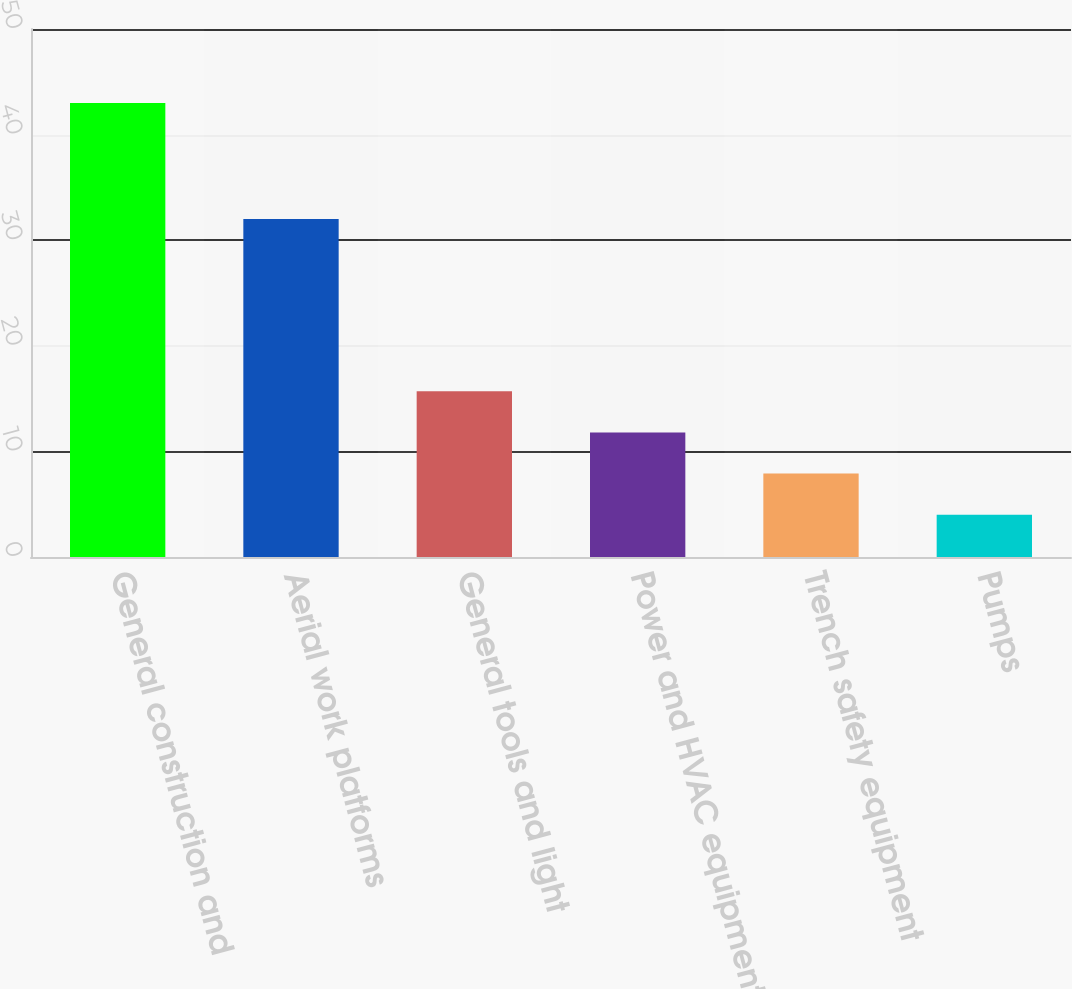Convert chart to OTSL. <chart><loc_0><loc_0><loc_500><loc_500><bar_chart><fcel>General construction and<fcel>Aerial work platforms<fcel>General tools and light<fcel>Power and HVAC equipment<fcel>Trench safety equipment<fcel>Pumps<nl><fcel>43<fcel>32<fcel>15.7<fcel>11.8<fcel>7.9<fcel>4<nl></chart> 